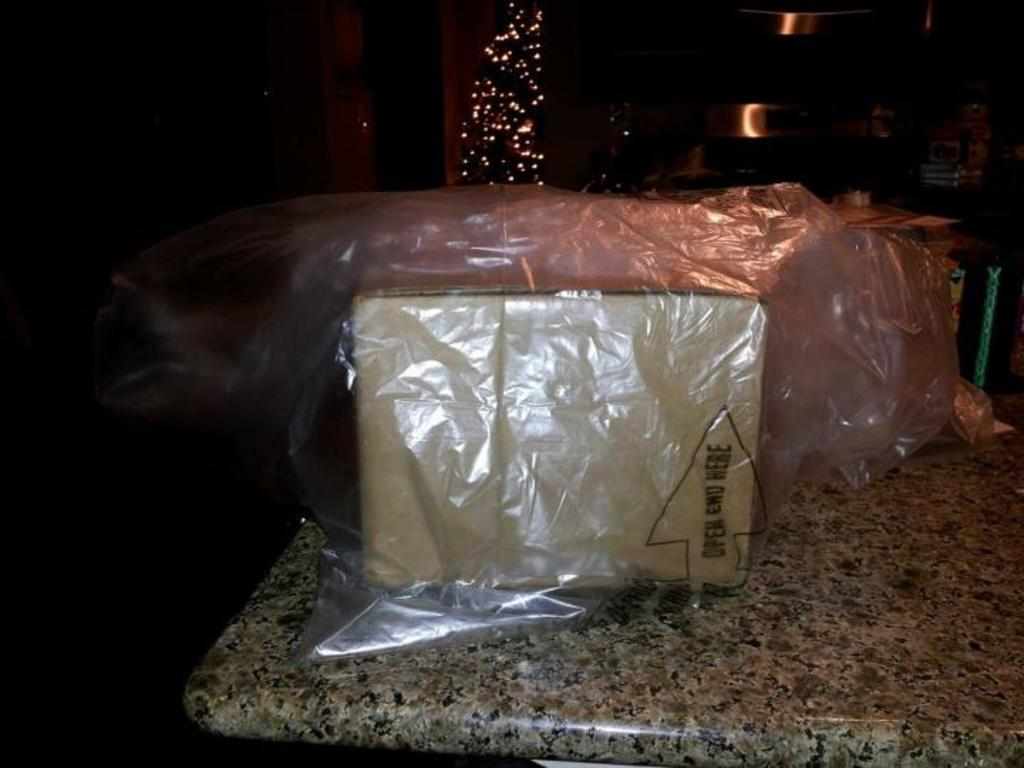What type of object is depicted in the image? There is a cartoon box in the image. Is there any covering or protection in the image? Yes, there is a cover in the image. What else can be seen in the image besides the cartoon box and cover? There are vessels and objects on a table in the image. What can be seen in the background of the image? There is a wall and lights in the background of the image. Where might this image have been taken? The image is likely taken in a room, given the presence of a table and wall in the background. What type of powder is being used to clean the screws in the image? There is no powder or screws present in the image; it features a cartoon box, cover, vessels, and objects on a table in a room. 